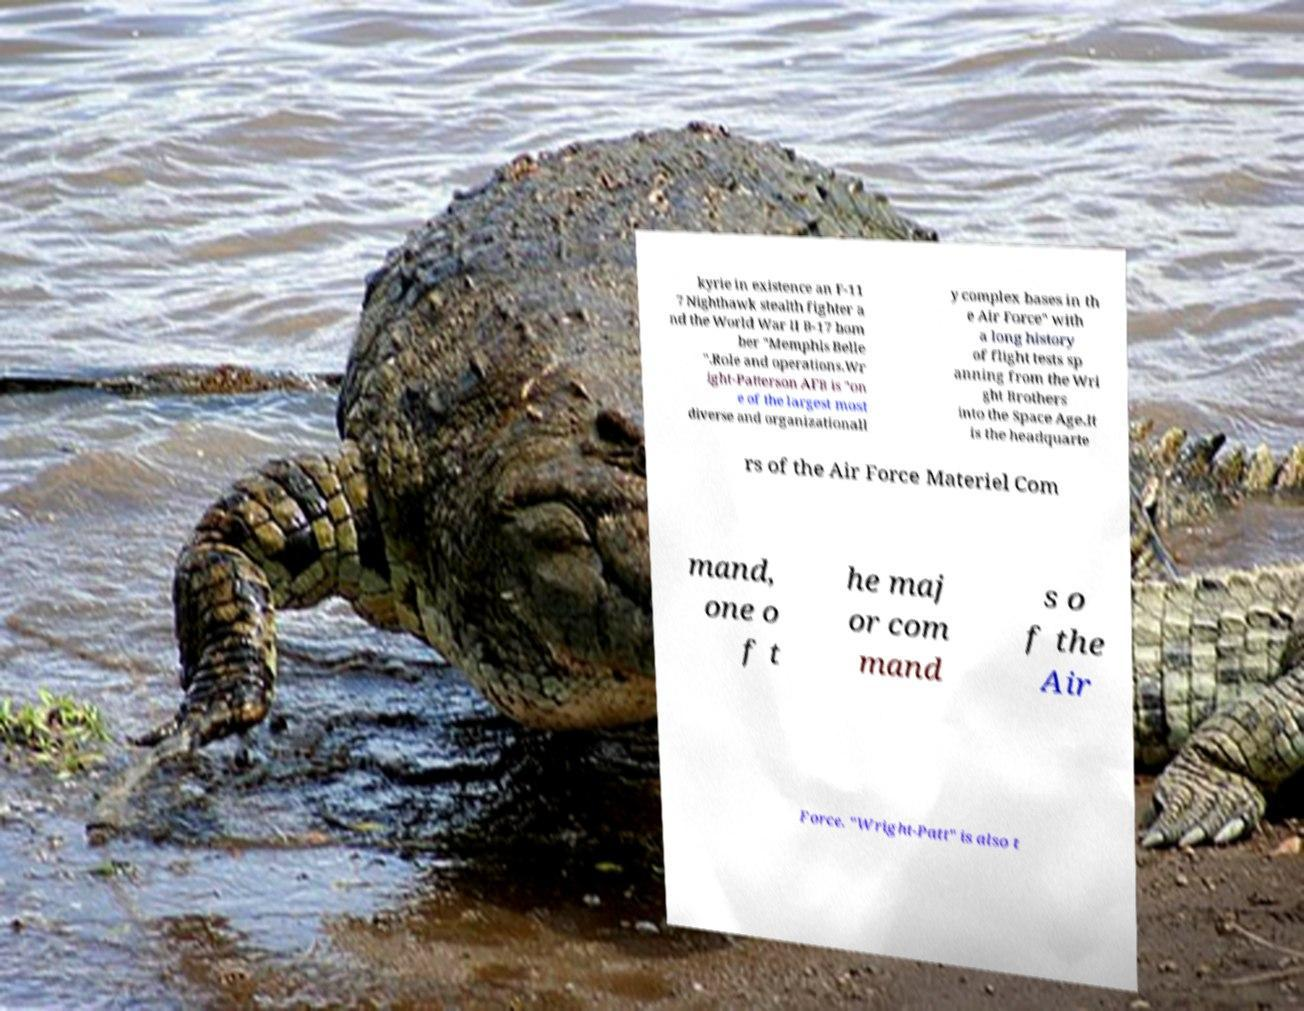What messages or text are displayed in this image? I need them in a readable, typed format. kyrie in existence an F-11 7 Nighthawk stealth fighter a nd the World War II B-17 bom ber "Memphis Belle ".Role and operations.Wr ight-Patterson AFB is "on e of the largest most diverse and organizationall y complex bases in th e Air Force" with a long history of flight tests sp anning from the Wri ght Brothers into the Space Age.It is the headquarte rs of the Air Force Materiel Com mand, one o f t he maj or com mand s o f the Air Force. "Wright-Patt" is also t 